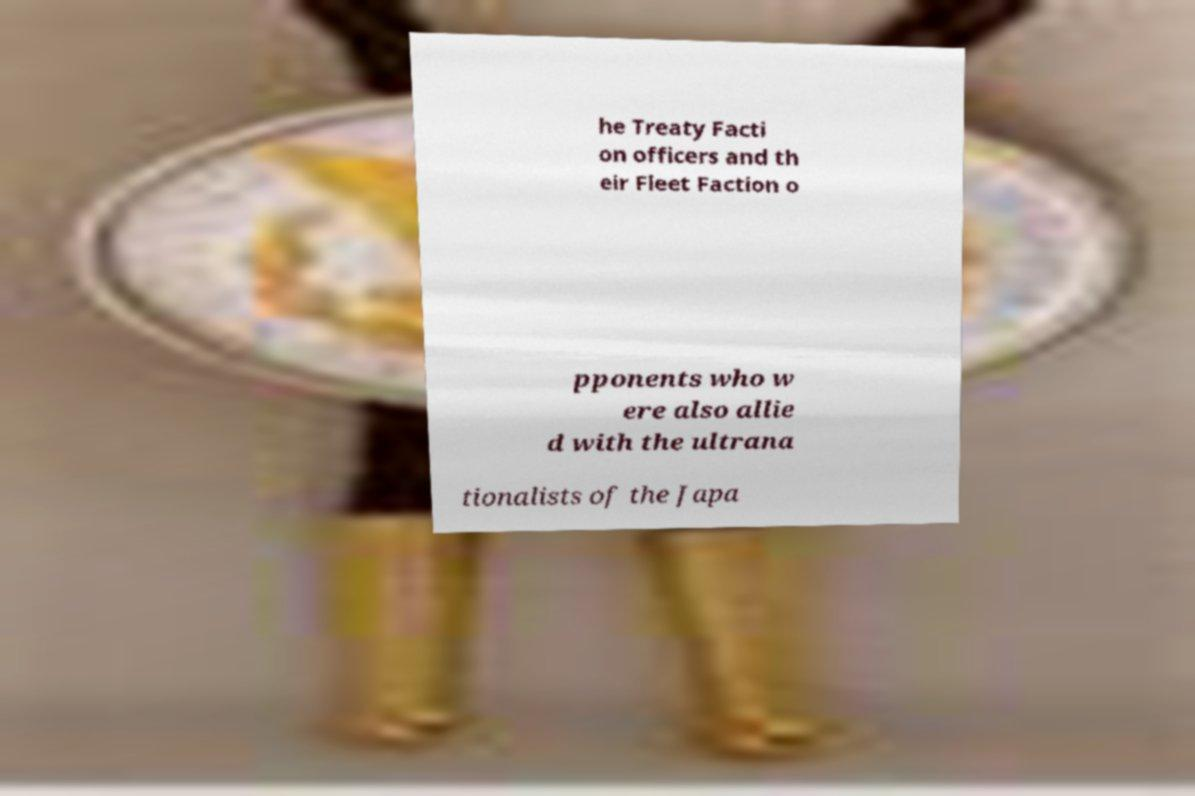For documentation purposes, I need the text within this image transcribed. Could you provide that? he Treaty Facti on officers and th eir Fleet Faction o pponents who w ere also allie d with the ultrana tionalists of the Japa 